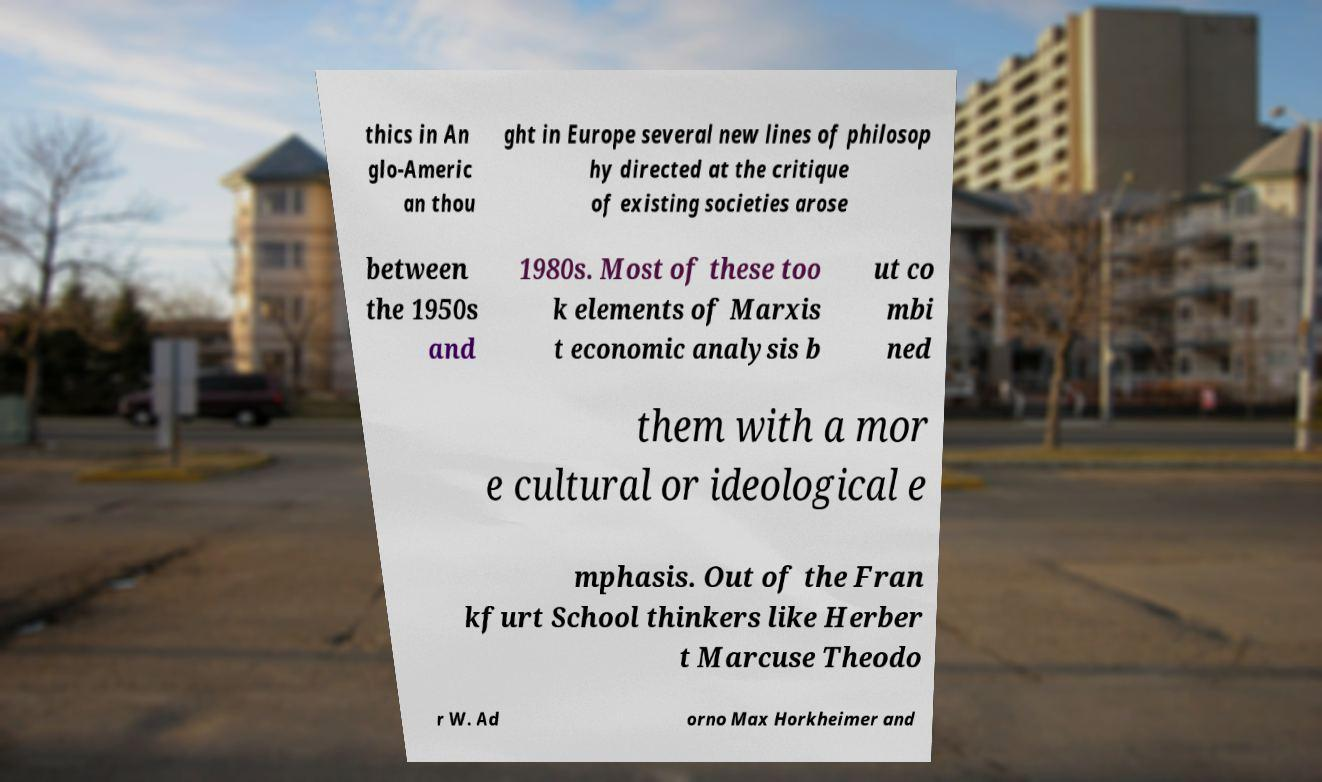What messages or text are displayed in this image? I need them in a readable, typed format. thics in An glo-Americ an thou ght in Europe several new lines of philosop hy directed at the critique of existing societies arose between the 1950s and 1980s. Most of these too k elements of Marxis t economic analysis b ut co mbi ned them with a mor e cultural or ideological e mphasis. Out of the Fran kfurt School thinkers like Herber t Marcuse Theodo r W. Ad orno Max Horkheimer and 